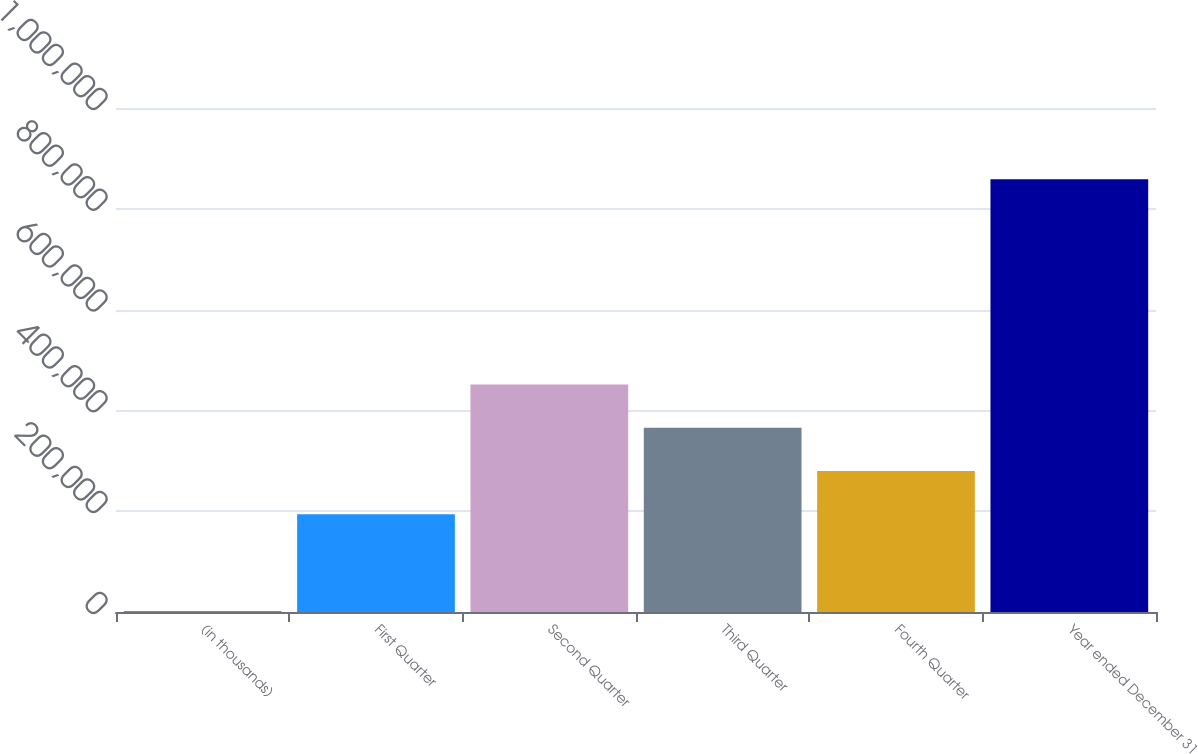Convert chart to OTSL. <chart><loc_0><loc_0><loc_500><loc_500><bar_chart><fcel>(in thousands)<fcel>First Quarter<fcel>Second Quarter<fcel>Third Quarter<fcel>Fourth Quarter<fcel>Year ended December 31<nl><fcel>2006<fcel>194187<fcel>451249<fcel>365561<fcel>279874<fcel>858878<nl></chart> 